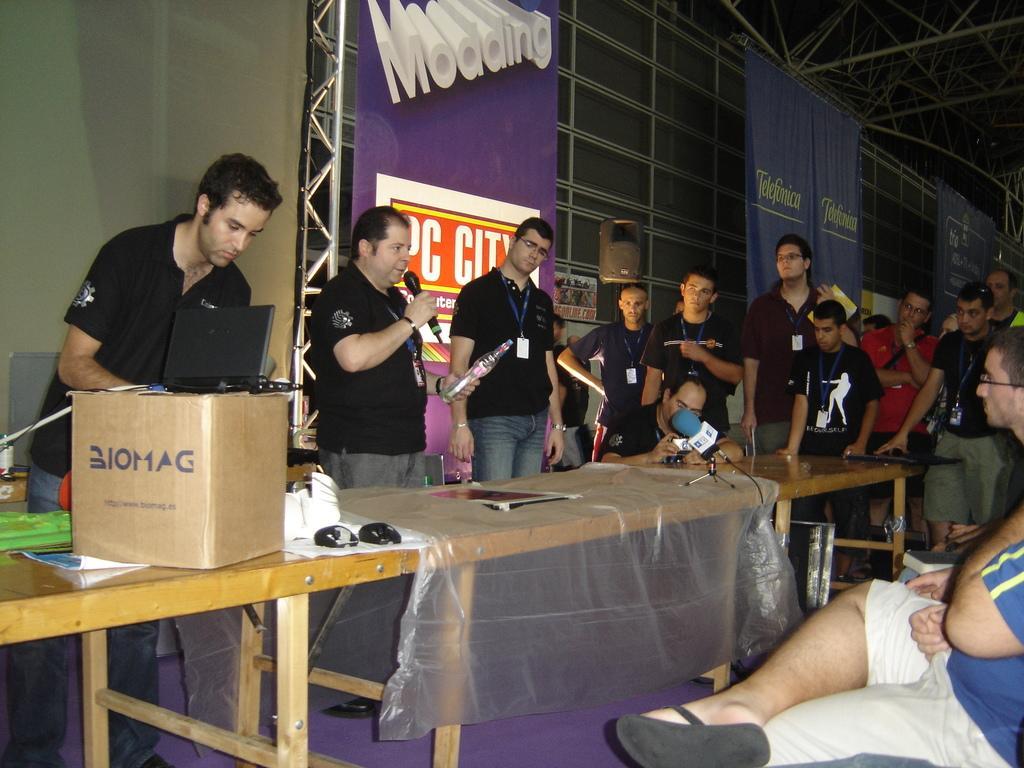Can you describe this image briefly? In the picture there are many persons standing and some people are sitting a person is talking in a micro phone by catching a bottle with his hand in front of him there is a table on the table there is a cardboard box laptop microphones mouse tissues bottles behind them there is a banner on the pole ,on the banner there is some text. 